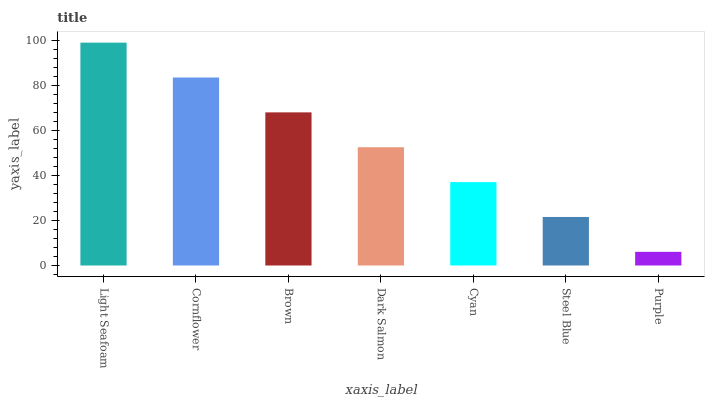Is Purple the minimum?
Answer yes or no. Yes. Is Light Seafoam the maximum?
Answer yes or no. Yes. Is Cornflower the minimum?
Answer yes or no. No. Is Cornflower the maximum?
Answer yes or no. No. Is Light Seafoam greater than Cornflower?
Answer yes or no. Yes. Is Cornflower less than Light Seafoam?
Answer yes or no. Yes. Is Cornflower greater than Light Seafoam?
Answer yes or no. No. Is Light Seafoam less than Cornflower?
Answer yes or no. No. Is Dark Salmon the high median?
Answer yes or no. Yes. Is Dark Salmon the low median?
Answer yes or no. Yes. Is Steel Blue the high median?
Answer yes or no. No. Is Cornflower the low median?
Answer yes or no. No. 